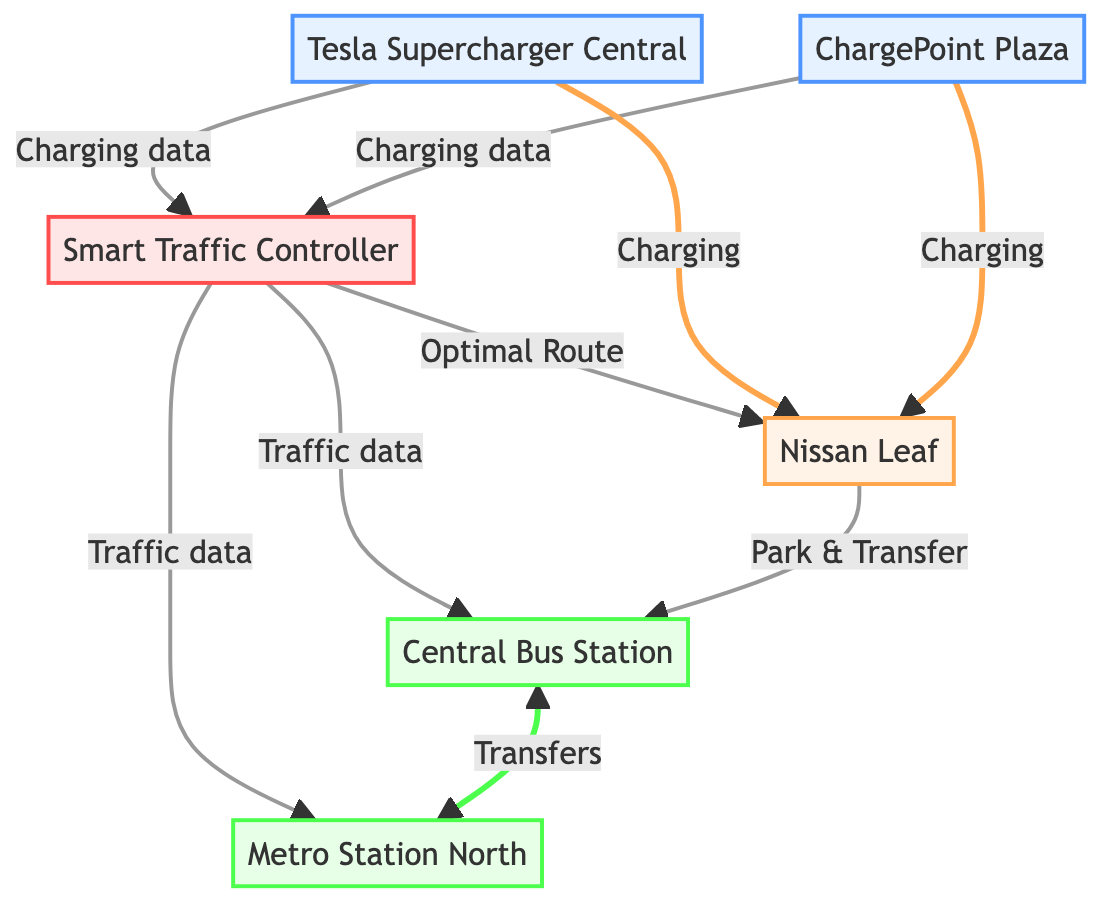What is the location of Tesla Supercharger Central? Tesla Supercharger Central is located in Downtown, as indicated in the node's details.
Answer: Downtown How many charging stations are in the network? There are two charging stations depicted in the diagram: Tesla Supercharger Central and ChargePoint Plaza.
Answer: 2 What type of data is exchanged between the charging stations and the traffic management system? The arrows from the charging stations to the traffic management system denote the flow of charging data and station availability information.
Answer: Charging data What is the main function of the Smart Traffic Controller? The Smart Traffic Controller primarily provides optimal route suggestions with live traffic updates to the electric vehicle.
Answer: Optimal Route Which public transport nodes are connected directly to the Smart Traffic Controller? The Smart Traffic Controller connects directly to two public transport nodes: Central Bus Station and Metro Station North, indicated by the arrows in the diagram.
Answer: Central Bus Station and Metro Station North What is the relationship between Central Bus Station and Metro Station North? The Central Bus Station and Metro Station North are connected through passenger transfers and schedules, as shown by the two-way arrow between them.
Answer: Transfers How does the electric vehicle interact with the public transport node in Downtown? The electric vehicle parks and transfers to public transport at the Central Bus Station, as indicated by the arrow from the EV to that node.
Answer: Park & Transfer What type of service is provided by the EV Charging Station 1 to the Nissan Leaf? The EV Charging Station 1 provides a charging service to the Nissan Leaf, as indicated by the arrow labeled "Charging."
Answer: Charging How many edges are in the diagram? The diagram contains a total of eight edges that represent various relationships and data flows among the nodes.
Answer: 8 